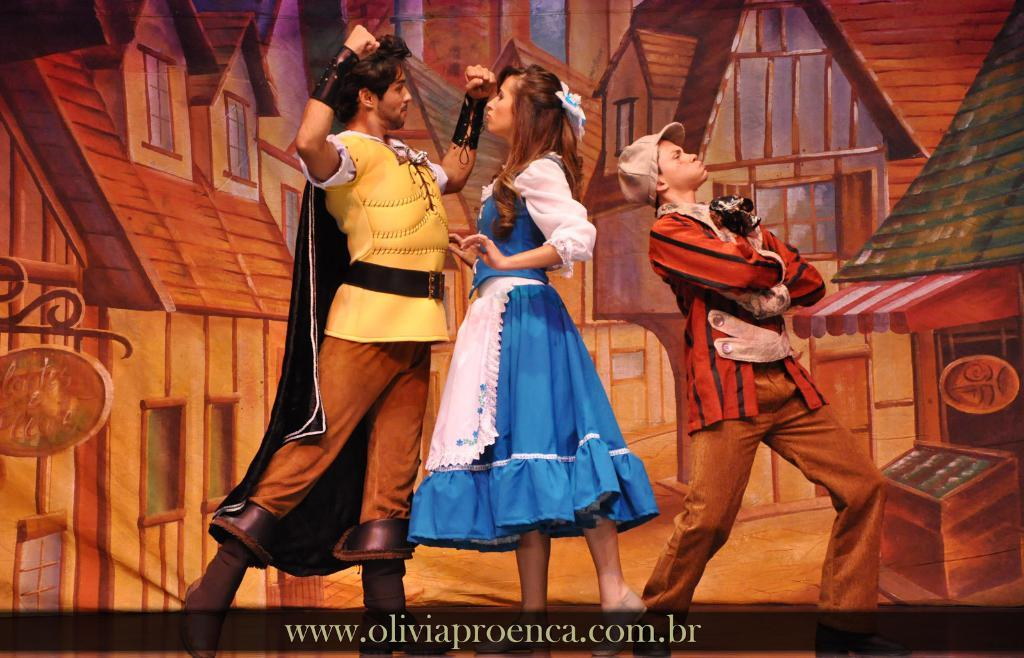How many people are present in the image? There are three people in the image. Can you describe the background of the image? There is a painting of houses in the background of the image. What type of volleyball game is being played in the image? There is no volleyball game present in the image. How does the sink contribute to the scene in the image? There is no sink present in the image. 